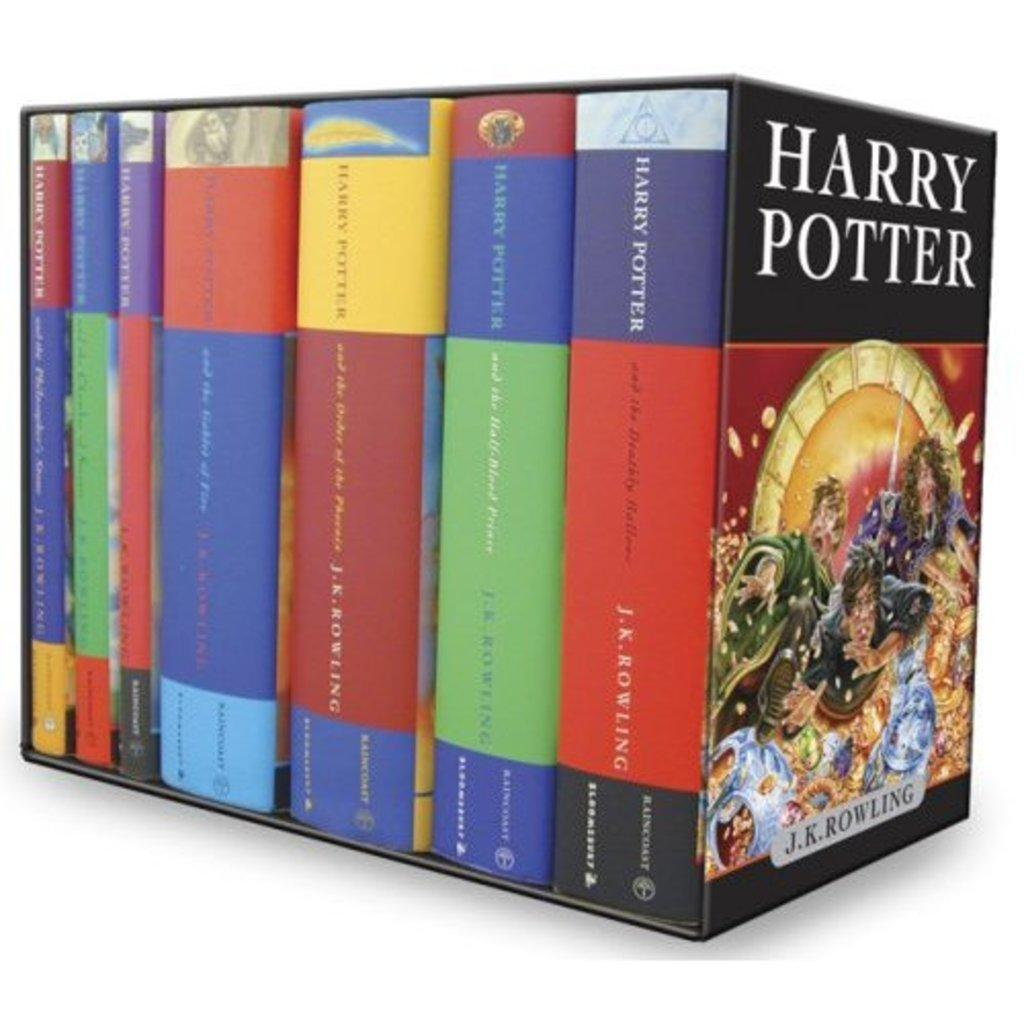<image>
Relay a brief, clear account of the picture shown. The Harry Potter book series arranged in a full box set. 